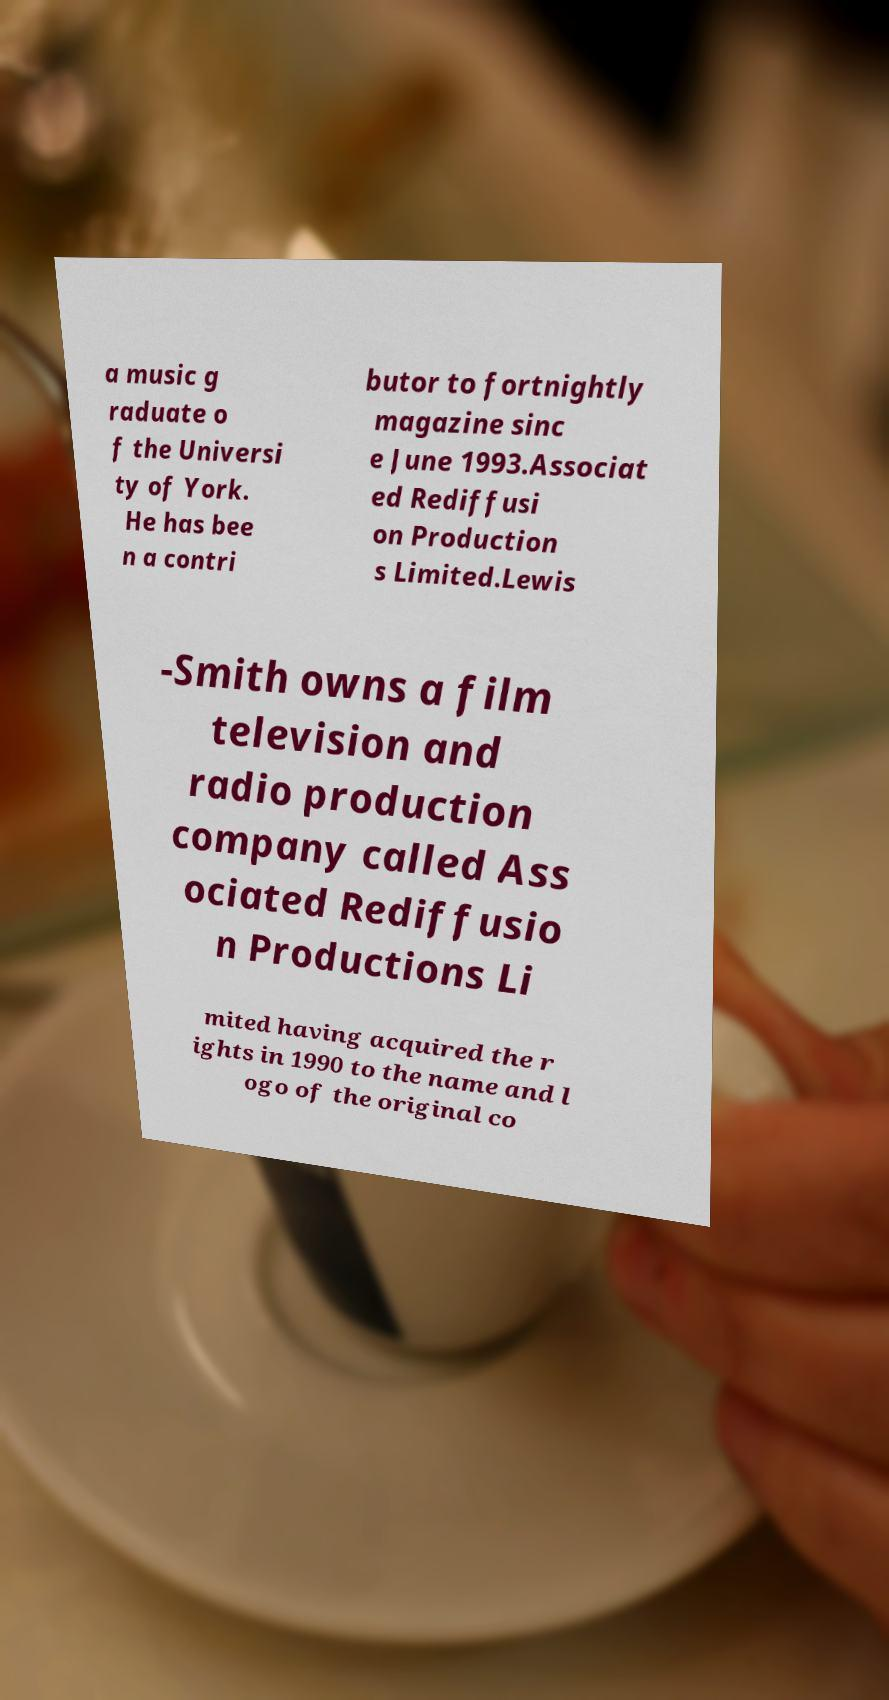There's text embedded in this image that I need extracted. Can you transcribe it verbatim? a music g raduate o f the Universi ty of York. He has bee n a contri butor to fortnightly magazine sinc e June 1993.Associat ed Rediffusi on Production s Limited.Lewis -Smith owns a film television and radio production company called Ass ociated Rediffusio n Productions Li mited having acquired the r ights in 1990 to the name and l ogo of the original co 